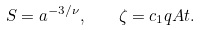<formula> <loc_0><loc_0><loc_500><loc_500>S = a ^ { - 3 / \nu } , \quad \zeta = c _ { 1 } q A t .</formula> 